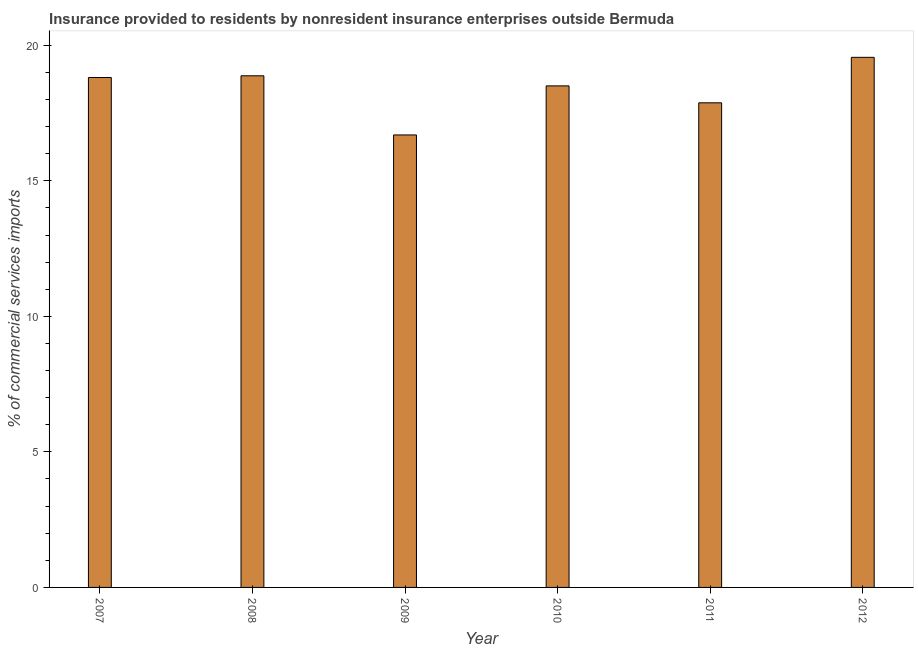What is the title of the graph?
Keep it short and to the point. Insurance provided to residents by nonresident insurance enterprises outside Bermuda. What is the label or title of the Y-axis?
Your answer should be very brief. % of commercial services imports. What is the insurance provided by non-residents in 2009?
Your answer should be very brief. 16.69. Across all years, what is the maximum insurance provided by non-residents?
Offer a terse response. 19.56. Across all years, what is the minimum insurance provided by non-residents?
Ensure brevity in your answer.  16.69. In which year was the insurance provided by non-residents minimum?
Ensure brevity in your answer.  2009. What is the sum of the insurance provided by non-residents?
Ensure brevity in your answer.  110.31. What is the difference between the insurance provided by non-residents in 2007 and 2011?
Your response must be concise. 0.93. What is the average insurance provided by non-residents per year?
Offer a very short reply. 18.39. What is the median insurance provided by non-residents?
Offer a very short reply. 18.66. Do a majority of the years between 2008 and 2011 (inclusive) have insurance provided by non-residents greater than 1 %?
Make the answer very short. Yes. What is the ratio of the insurance provided by non-residents in 2009 to that in 2012?
Give a very brief answer. 0.85. What is the difference between the highest and the second highest insurance provided by non-residents?
Keep it short and to the point. 0.68. What is the difference between the highest and the lowest insurance provided by non-residents?
Ensure brevity in your answer.  2.86. In how many years, is the insurance provided by non-residents greater than the average insurance provided by non-residents taken over all years?
Provide a succinct answer. 4. How many years are there in the graph?
Your answer should be compact. 6. What is the difference between two consecutive major ticks on the Y-axis?
Keep it short and to the point. 5. Are the values on the major ticks of Y-axis written in scientific E-notation?
Give a very brief answer. No. What is the % of commercial services imports of 2007?
Make the answer very short. 18.81. What is the % of commercial services imports of 2008?
Your answer should be very brief. 18.87. What is the % of commercial services imports of 2009?
Give a very brief answer. 16.69. What is the % of commercial services imports in 2010?
Your answer should be very brief. 18.5. What is the % of commercial services imports in 2011?
Keep it short and to the point. 17.88. What is the % of commercial services imports of 2012?
Provide a short and direct response. 19.56. What is the difference between the % of commercial services imports in 2007 and 2008?
Offer a very short reply. -0.06. What is the difference between the % of commercial services imports in 2007 and 2009?
Give a very brief answer. 2.12. What is the difference between the % of commercial services imports in 2007 and 2010?
Your answer should be very brief. 0.31. What is the difference between the % of commercial services imports in 2007 and 2011?
Your answer should be compact. 0.93. What is the difference between the % of commercial services imports in 2007 and 2012?
Ensure brevity in your answer.  -0.74. What is the difference between the % of commercial services imports in 2008 and 2009?
Keep it short and to the point. 2.18. What is the difference between the % of commercial services imports in 2008 and 2010?
Your answer should be very brief. 0.37. What is the difference between the % of commercial services imports in 2008 and 2011?
Offer a terse response. 1. What is the difference between the % of commercial services imports in 2008 and 2012?
Offer a very short reply. -0.68. What is the difference between the % of commercial services imports in 2009 and 2010?
Offer a terse response. -1.81. What is the difference between the % of commercial services imports in 2009 and 2011?
Make the answer very short. -1.19. What is the difference between the % of commercial services imports in 2009 and 2012?
Your response must be concise. -2.86. What is the difference between the % of commercial services imports in 2010 and 2011?
Your answer should be compact. 0.63. What is the difference between the % of commercial services imports in 2010 and 2012?
Give a very brief answer. -1.05. What is the difference between the % of commercial services imports in 2011 and 2012?
Keep it short and to the point. -1.68. What is the ratio of the % of commercial services imports in 2007 to that in 2009?
Give a very brief answer. 1.13. What is the ratio of the % of commercial services imports in 2007 to that in 2010?
Offer a very short reply. 1.02. What is the ratio of the % of commercial services imports in 2007 to that in 2011?
Your answer should be very brief. 1.05. What is the ratio of the % of commercial services imports in 2008 to that in 2009?
Your answer should be very brief. 1.13. What is the ratio of the % of commercial services imports in 2008 to that in 2011?
Your answer should be compact. 1.06. What is the ratio of the % of commercial services imports in 2008 to that in 2012?
Offer a terse response. 0.96. What is the ratio of the % of commercial services imports in 2009 to that in 2010?
Offer a terse response. 0.9. What is the ratio of the % of commercial services imports in 2009 to that in 2011?
Your answer should be very brief. 0.93. What is the ratio of the % of commercial services imports in 2009 to that in 2012?
Keep it short and to the point. 0.85. What is the ratio of the % of commercial services imports in 2010 to that in 2011?
Your response must be concise. 1.03. What is the ratio of the % of commercial services imports in 2010 to that in 2012?
Offer a terse response. 0.95. What is the ratio of the % of commercial services imports in 2011 to that in 2012?
Offer a terse response. 0.91. 